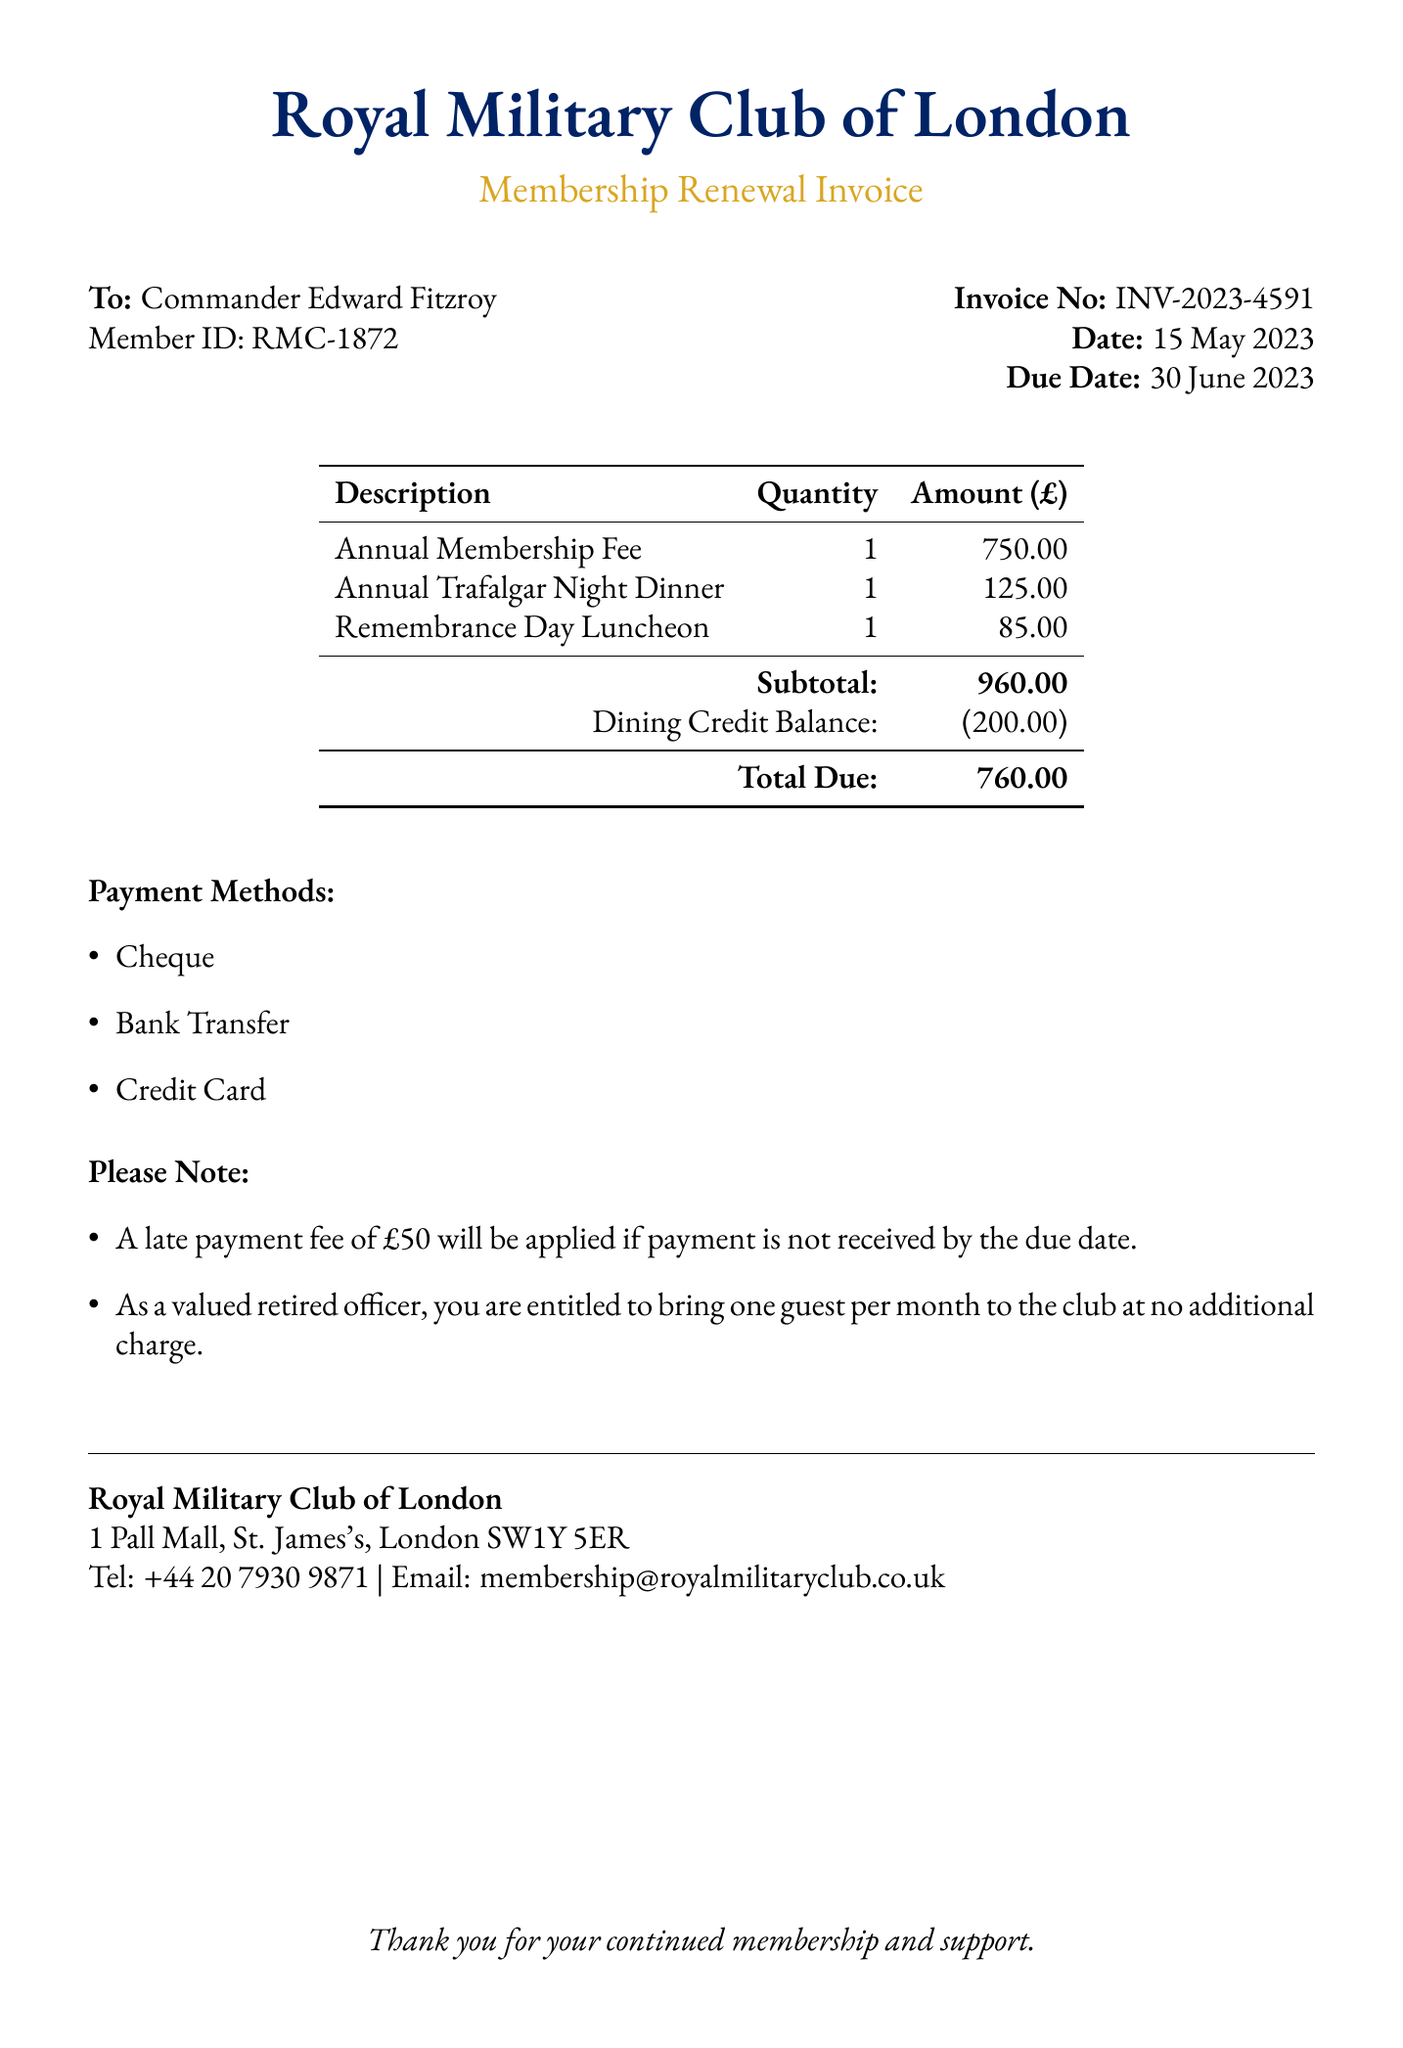what is the member ID? The member ID is specifically mentioned in the document as RMC-1872.
Answer: RMC-1872 what is the date of the invoice? The date is stated clearly in the document as 15 May 2023.
Answer: 15 May 2023 how much is the annual membership fee? The annual membership fee listed in the document is £750.00.
Answer: £750.00 what is the total due amount? The total due amount is calculated from the subtotal and dining credit balance, presented as £760.00.
Answer: £760.00 when is the payment due date? The due date for payment is explicitly mentioned as 30 June 2023.
Answer: 30 June 2023 how much is the dining credit balance? The dining credit balance indicated in the document is (£200.00).
Answer: (£200.00) what penalty is there for late payment? The late payment fee specified in the document is £50.
Answer: £50 how many guests can a retired officer bring to the club monthly at no charge? The document states a retired officer can bring one guest per month.
Answer: one guest what are the payment methods listed? The document lists cheque, bank transfer, and credit card as payment methods.
Answer: cheque, bank transfer, credit card 